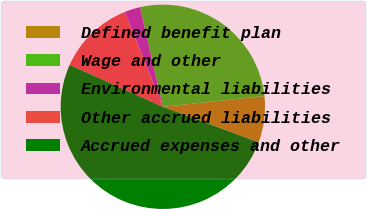Convert chart to OTSL. <chart><loc_0><loc_0><loc_500><loc_500><pie_chart><fcel>Defined benefit plan<fcel>Wage and other<fcel>Environmental liabilities<fcel>Other accrued liabilities<fcel>Accrued expenses and other<nl><fcel>7.34%<fcel>26.91%<fcel>2.49%<fcel>12.2%<fcel>51.06%<nl></chart> 